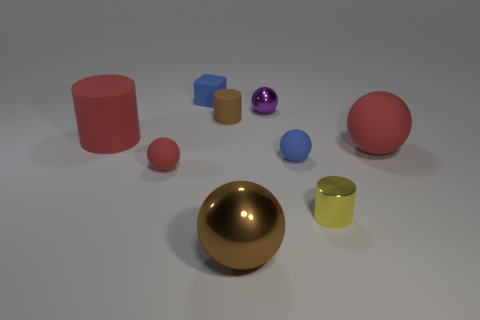Subtract all metal cylinders. How many cylinders are left? 2 Add 1 small gray matte objects. How many objects exist? 10 Add 8 purple objects. How many purple objects are left? 9 Add 2 big red matte things. How many big red matte things exist? 4 Subtract all red cylinders. How many cylinders are left? 2 Subtract 0 gray blocks. How many objects are left? 9 Subtract all spheres. How many objects are left? 4 Subtract 1 cylinders. How many cylinders are left? 2 Subtract all yellow cylinders. Subtract all red balls. How many cylinders are left? 2 Subtract all green cylinders. How many yellow blocks are left? 0 